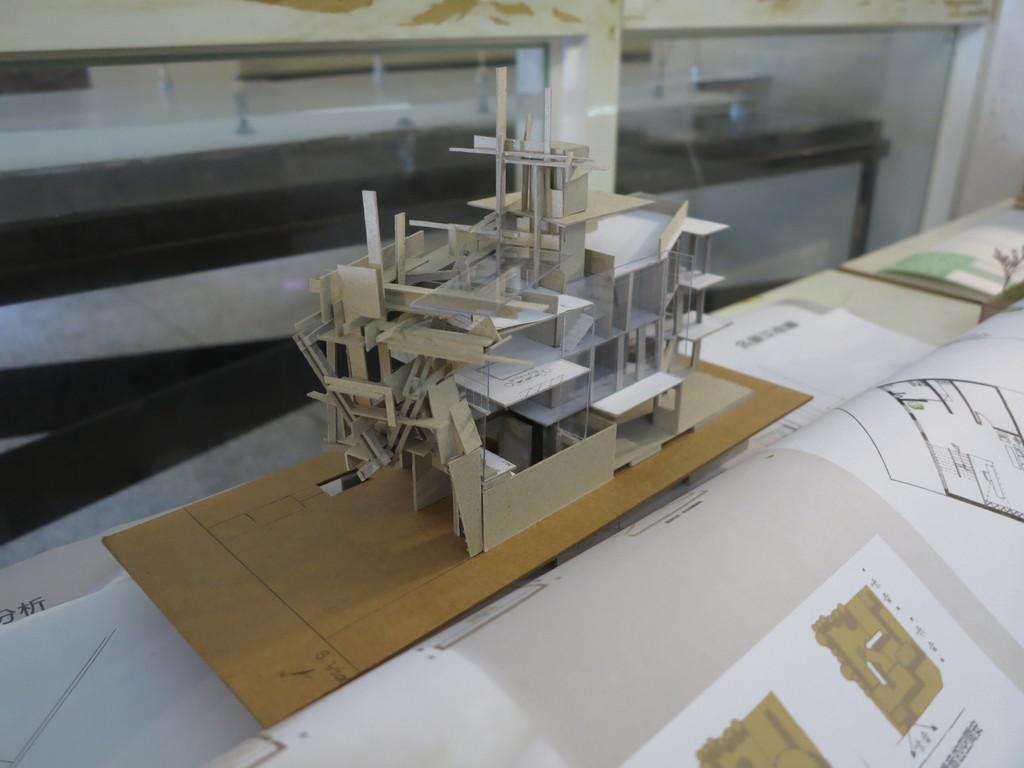Please provide a concise description of this image. In this image we can see the table, on the table there are papers and wooden board, on that we can see the building which made by an object. At the back we can see the glass and the black color object. 